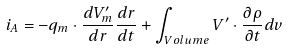Convert formula to latex. <formula><loc_0><loc_0><loc_500><loc_500>i _ { A } = - q _ { m } \cdot \frac { d V ^ { \prime } _ { m } } { d { r } } \frac { d { r } } { d t } + \int _ { V o l u m e } { V ^ { \prime } \cdot \frac { \partial \rho } { \partial t } d v }</formula> 